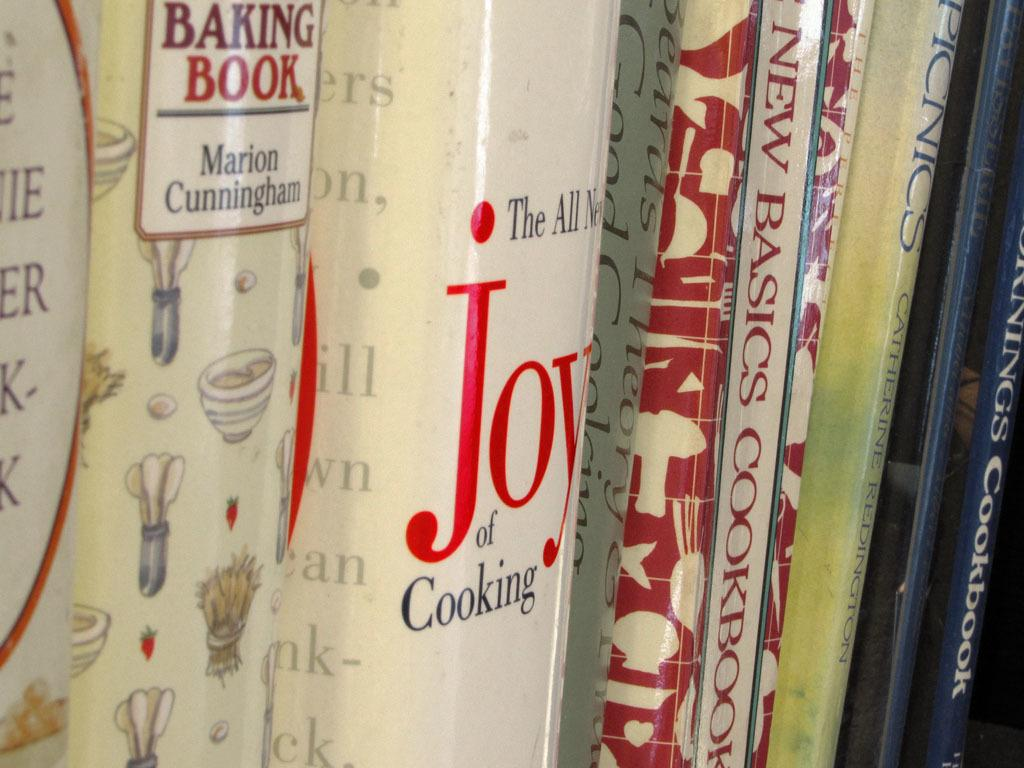<image>
Provide a brief description of the given image. Books are sitting in a row including the Joy of Cooking. 